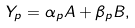<formula> <loc_0><loc_0><loc_500><loc_500>Y _ { p } = \alpha _ { p } A + \beta _ { p } B ,</formula> 